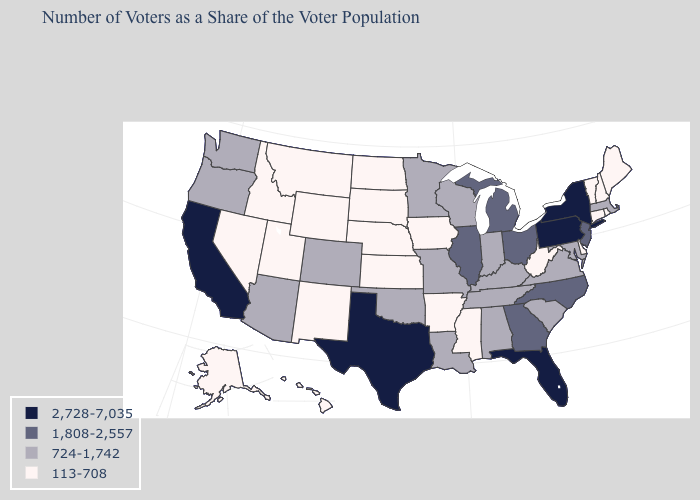Among the states that border Illinois , does Iowa have the highest value?
Keep it brief. No. What is the value of Indiana?
Short answer required. 724-1,742. Name the states that have a value in the range 113-708?
Be succinct. Alaska, Arkansas, Connecticut, Delaware, Hawaii, Idaho, Iowa, Kansas, Maine, Mississippi, Montana, Nebraska, Nevada, New Hampshire, New Mexico, North Dakota, Rhode Island, South Dakota, Utah, Vermont, West Virginia, Wyoming. Which states hav the highest value in the South?
Quick response, please. Florida, Texas. Name the states that have a value in the range 724-1,742?
Answer briefly. Alabama, Arizona, Colorado, Indiana, Kentucky, Louisiana, Maryland, Massachusetts, Minnesota, Missouri, Oklahoma, Oregon, South Carolina, Tennessee, Virginia, Washington, Wisconsin. What is the value of Indiana?
Quick response, please. 724-1,742. What is the value of North Carolina?
Be succinct. 1,808-2,557. Does Pennsylvania have the highest value in the USA?
Short answer required. Yes. What is the lowest value in states that border New Jersey?
Concise answer only. 113-708. Name the states that have a value in the range 113-708?
Give a very brief answer. Alaska, Arkansas, Connecticut, Delaware, Hawaii, Idaho, Iowa, Kansas, Maine, Mississippi, Montana, Nebraska, Nevada, New Hampshire, New Mexico, North Dakota, Rhode Island, South Dakota, Utah, Vermont, West Virginia, Wyoming. Which states have the highest value in the USA?
Short answer required. California, Florida, New York, Pennsylvania, Texas. Does Oklahoma have the same value as Colorado?
Keep it brief. Yes. Does Montana have the same value as Alaska?
Give a very brief answer. Yes. What is the highest value in the South ?
Give a very brief answer. 2,728-7,035. Among the states that border South Carolina , which have the lowest value?
Concise answer only. Georgia, North Carolina. 